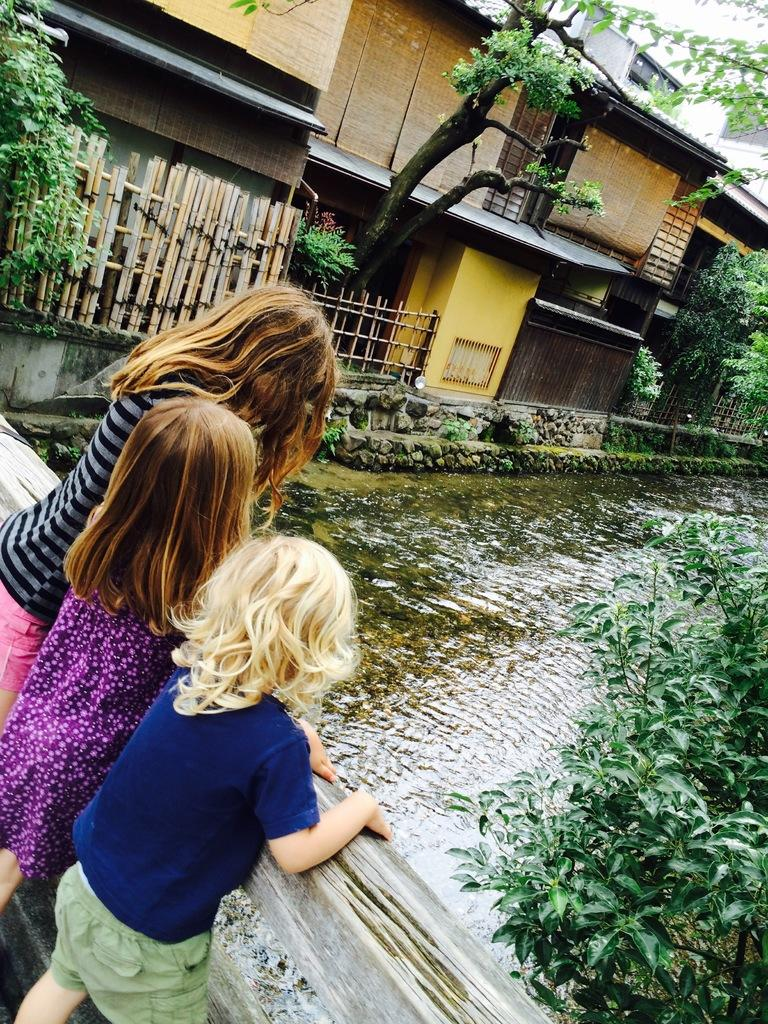What type of structures can be seen in the image? There are buildings in the image. What other natural elements are present in the image? There are trees and water visible in the image. What are the kids doing in the image? The kids are standing by holding a wooden fence. How many trains can be seen passing by in the image? There are no trains visible in the image. 